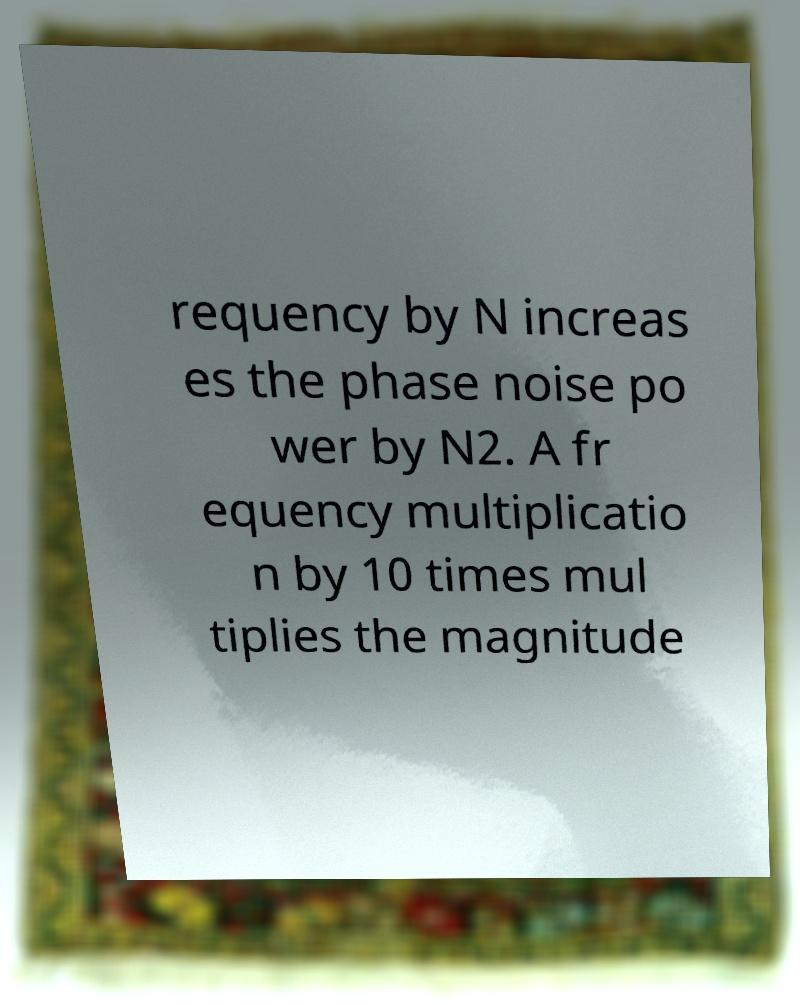Please identify and transcribe the text found in this image. requency by N increas es the phase noise po wer by N2. A fr equency multiplicatio n by 10 times mul tiplies the magnitude 